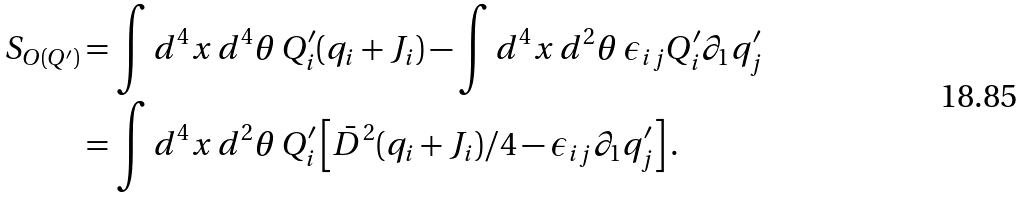<formula> <loc_0><loc_0><loc_500><loc_500>S _ { O ( Q ^ { \prime } ) } & = \int d ^ { 4 } x \, d ^ { 4 } \theta \, Q ^ { \prime } _ { i } ( q _ { i } + J _ { i } ) - \int d ^ { 4 } x \, d ^ { 2 } \theta \, \epsilon _ { i j } Q ^ { \prime } _ { i } \partial _ { 1 } q ^ { \prime } _ { j } \\ & = \int d ^ { 4 } x \, d ^ { 2 } \theta \, Q ^ { \prime } _ { i } \left [ \bar { D } ^ { 2 } ( q _ { i } + J _ { i } ) / 4 - \epsilon _ { i j } \partial _ { 1 } q ^ { \prime } _ { j } \right ] .</formula> 